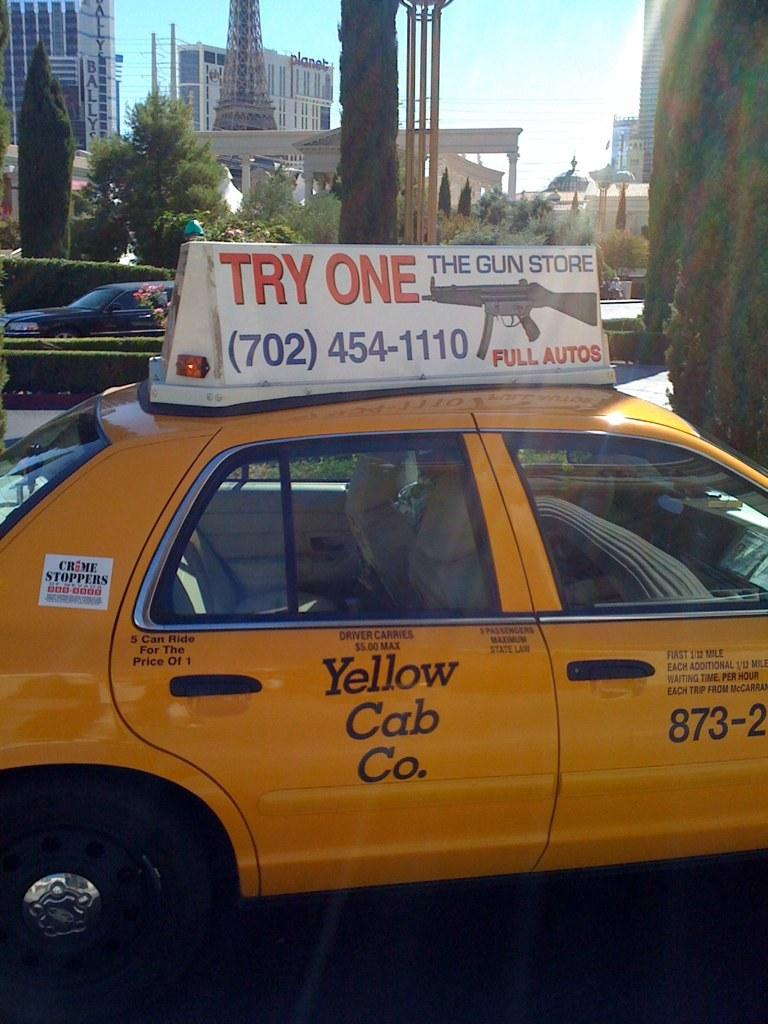Provide a one-sentence caption for the provided image. The taxi cab is promoting guns from The Gun Store. 